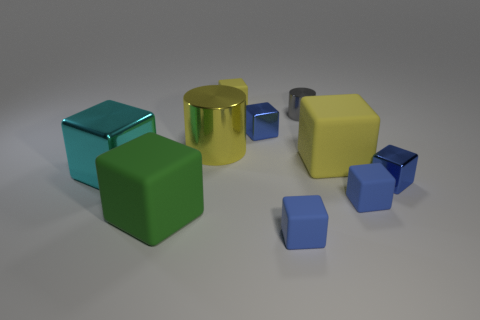Subtract all blue spheres. How many blue cubes are left? 4 Subtract 3 blocks. How many blocks are left? 5 Subtract all blue cubes. How many cubes are left? 4 Subtract all large cubes. How many cubes are left? 5 Subtract all cyan cubes. Subtract all green balls. How many cubes are left? 7 Subtract all blocks. How many objects are left? 2 Subtract 1 gray cylinders. How many objects are left? 9 Subtract all tiny blocks. Subtract all small blue metallic things. How many objects are left? 3 Add 4 cyan things. How many cyan things are left? 5 Add 2 gray cylinders. How many gray cylinders exist? 3 